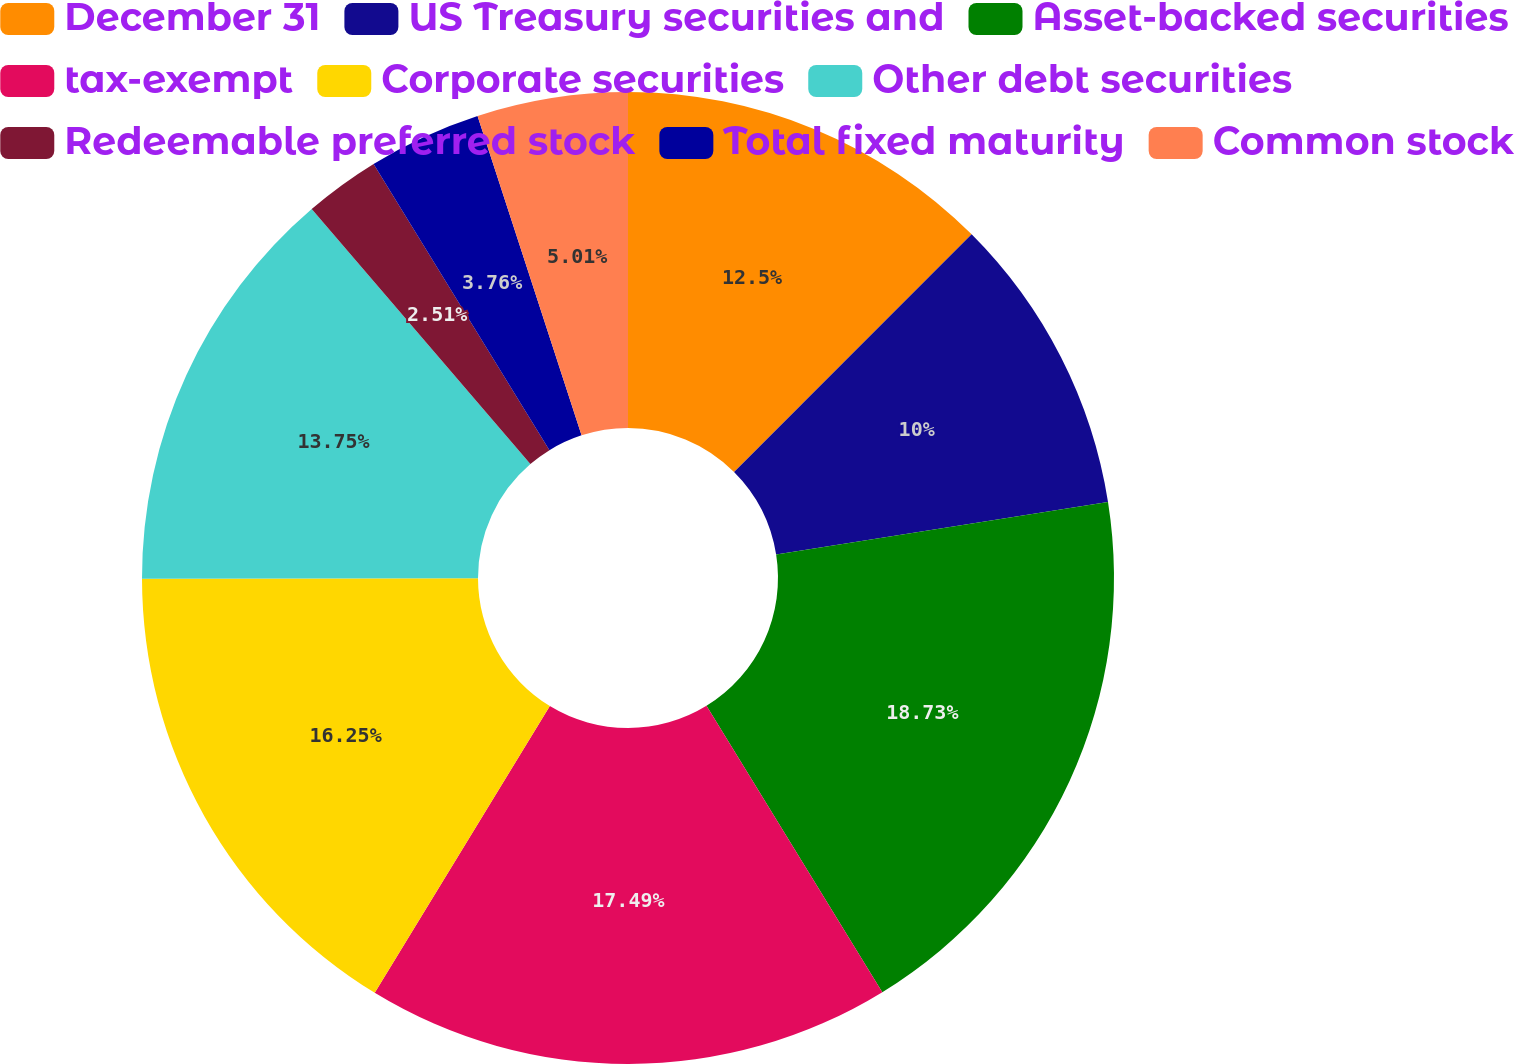Convert chart. <chart><loc_0><loc_0><loc_500><loc_500><pie_chart><fcel>December 31<fcel>US Treasury securities and<fcel>Asset-backed securities<fcel>tax-exempt<fcel>Corporate securities<fcel>Other debt securities<fcel>Redeemable preferred stock<fcel>Total fixed maturity<fcel>Common stock<nl><fcel>12.5%<fcel>10.0%<fcel>18.74%<fcel>17.49%<fcel>16.25%<fcel>13.75%<fcel>2.51%<fcel>3.76%<fcel>5.01%<nl></chart> 